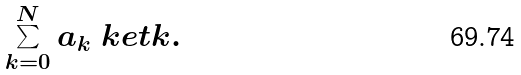<formula> <loc_0><loc_0><loc_500><loc_500>\sum _ { k = 0 } ^ { N } a _ { k } \ k e t { k } .</formula> 